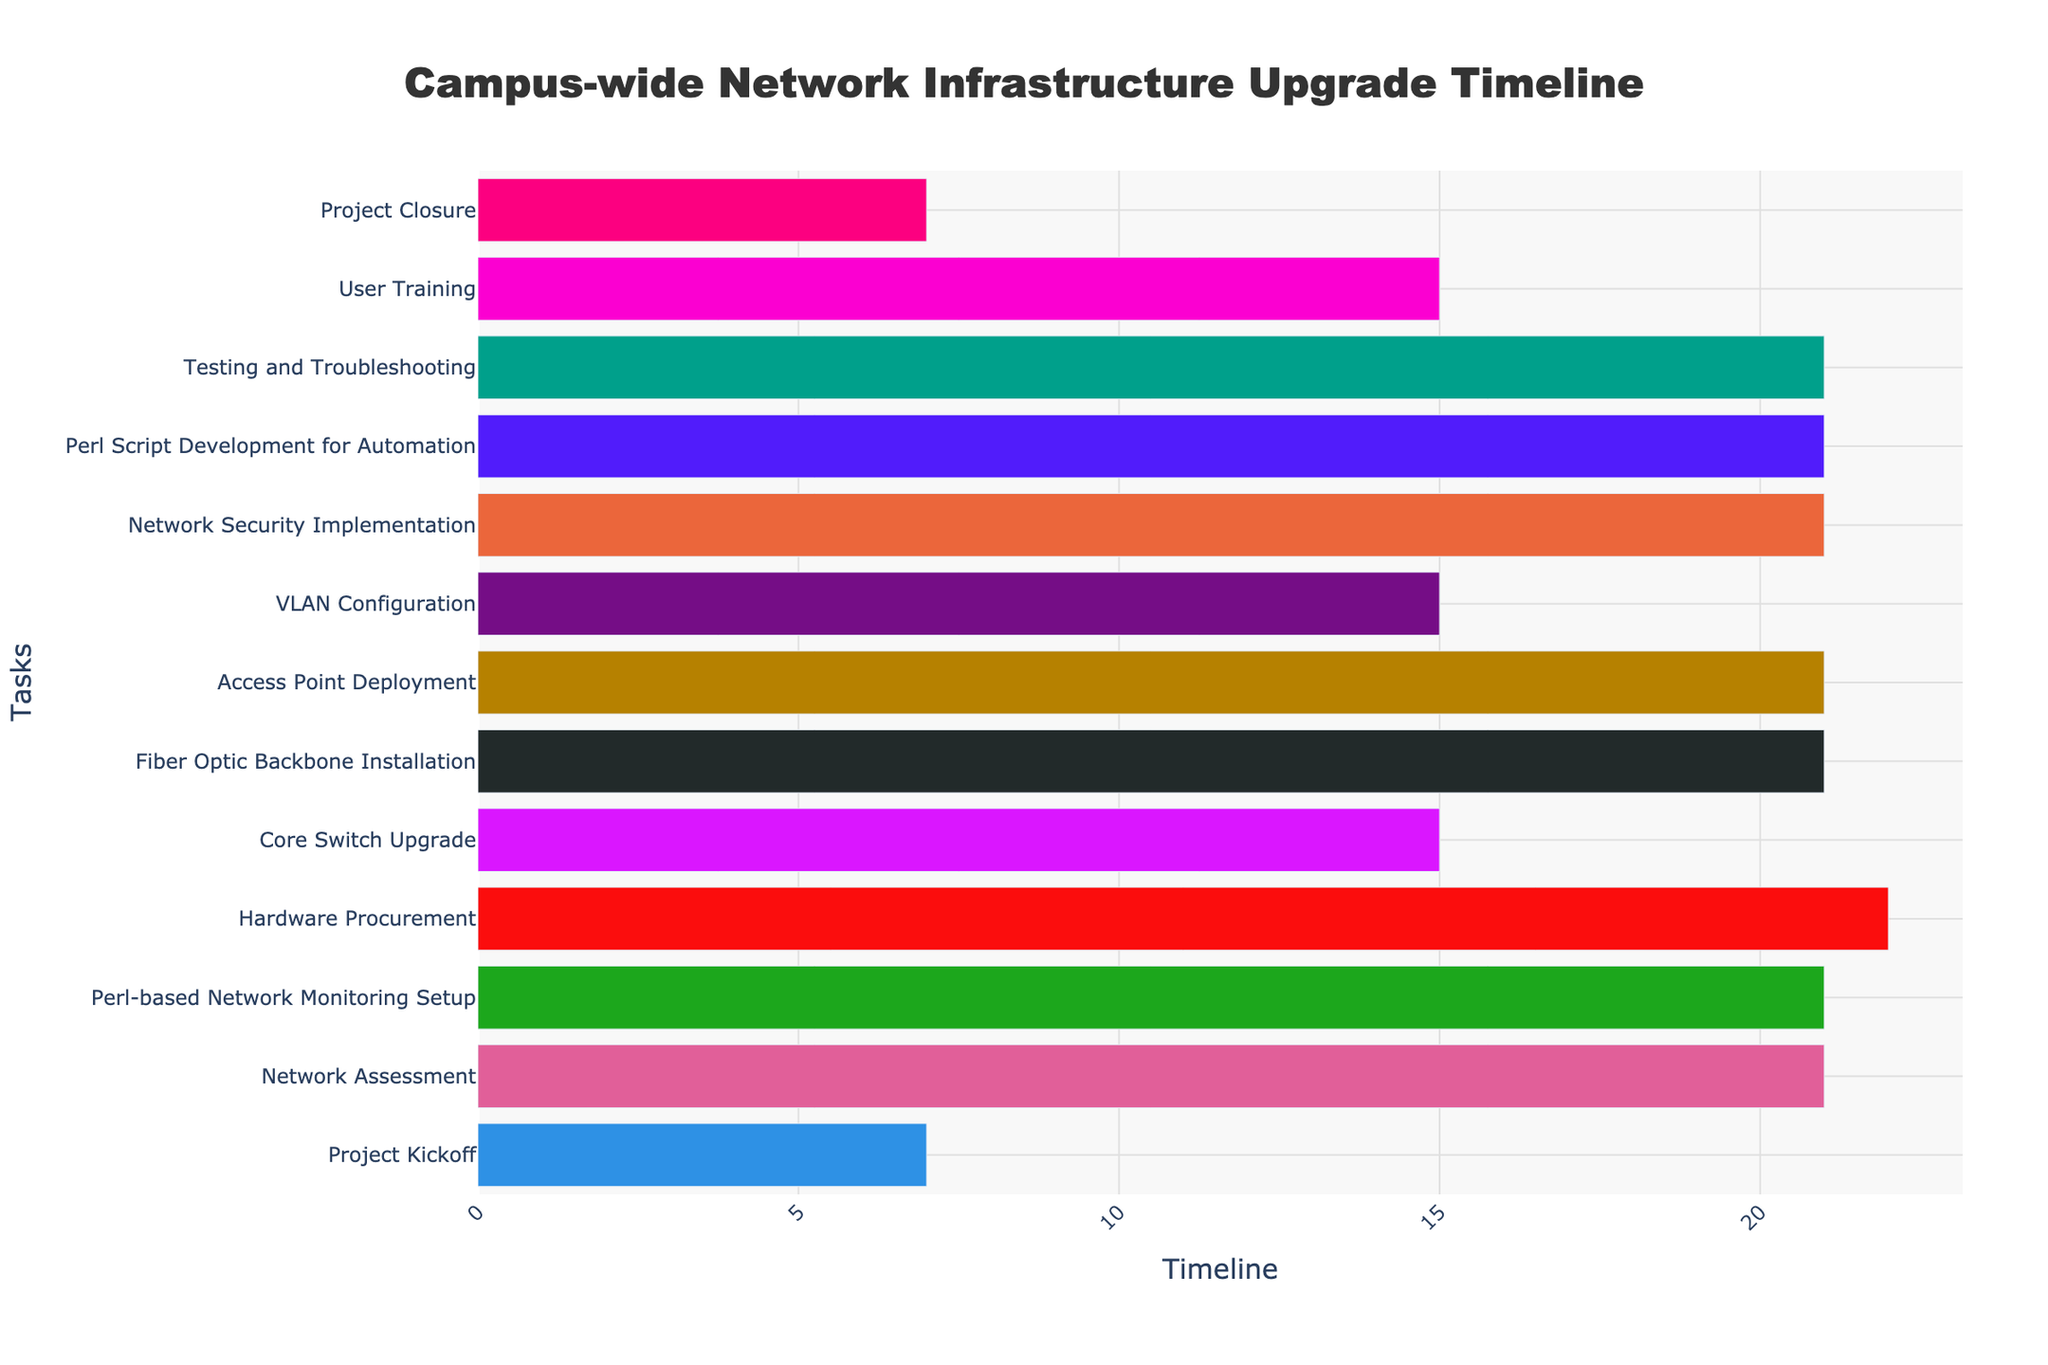Who is responsible for the longest task? The longest task in the figure is "Hardware Procurement," which spans from October 20, 2023, to November 10, 2023, lasting 22 days. This information is noted in the unordered list of tasks, the notable duration, and the supporting visual representation.
Answer: Hardware Procurement In what month does the "Core Switch Upgrade" start? The task "Core Switch Upgrade" starts on November 11, 2023, as indicated in the Gantt chart by the aligned bar date and the hover information displayed when exploring the chart visually.
Answer: November How many tasks are scheduled to end in March 2024? To find how many tasks end in March 2024, we examine the end dates of all tasks visually depicted on the chart. "Testing and Troubleshooting" ends on March 24, 2024, and "User Training" ends on April 8, 2024, hence there is only one task ending in March 2024.
Answer: 1 Which task follows directly after "Access Point Deployment"? "Access Point Deployment" ends on January 6, 2024, and the next task starting after this is "VLAN Configuration," which begins on January 7, 2024, according to the order of bars and their starting dates on the chart.
Answer: VLAN Configuration What's the difference in duration between "Network Assessment" and "Core Switch Upgrade"? To find the difference, we check the duration of each task. "Network Assessment" lasts 21 days, and "Core Switch Upgrade" lasts 15 days. The difference is 21 - 15 = 6 days.
Answer: 6 days Between which dates does the "Testing and Troubleshooting" phase occur? The "Testing and Troubleshooting" phase starts on March 4, 2024, and ends on March 24, 2024, as specified by the respective bar on the Gantt chart.
Answer: March 4, 2024 - March 24, 2024 How many tasks have a duration of exactly 21 days? By reviewing the duration of each task displayed on the chart, tasks like "Network Assessment," "Perl-based Network Monitoring Setup," "Fiber Optic Backbone Installation," "Access Point Deployment," "Network Security Implementation," "Perl Script Development for Automation," and "Testing and Troubleshooting" each last 21 days, totaling 7 tasks.
Answer: 7 tasks What is the total number of days planned for "Project Kickoff" and "Project Closure"? "Project Kickoff" lasts for 7 days, and "Project Closure" also spans 7 days. Adding their durations results in 7 + 7 = 14 days in total.
Answer: 14 days 